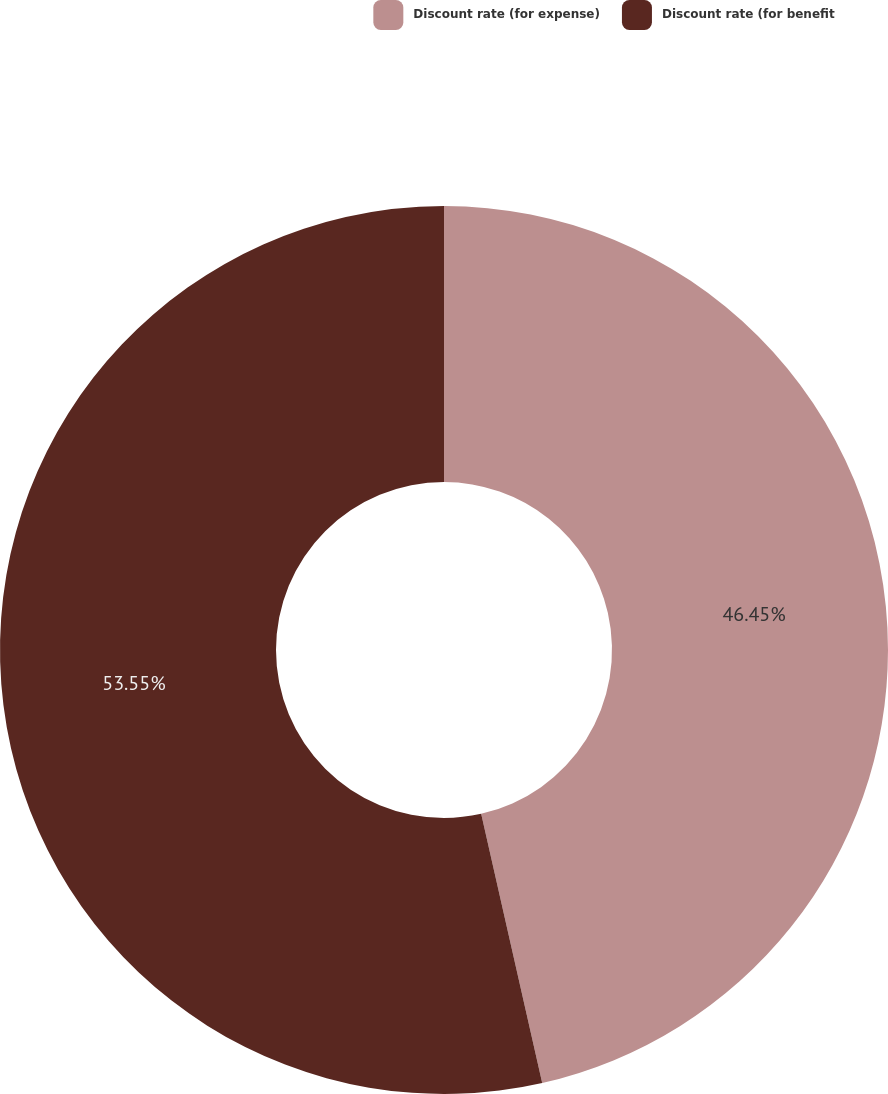<chart> <loc_0><loc_0><loc_500><loc_500><pie_chart><fcel>Discount rate (for expense)<fcel>Discount rate (for benefit<nl><fcel>46.45%<fcel>53.55%<nl></chart> 